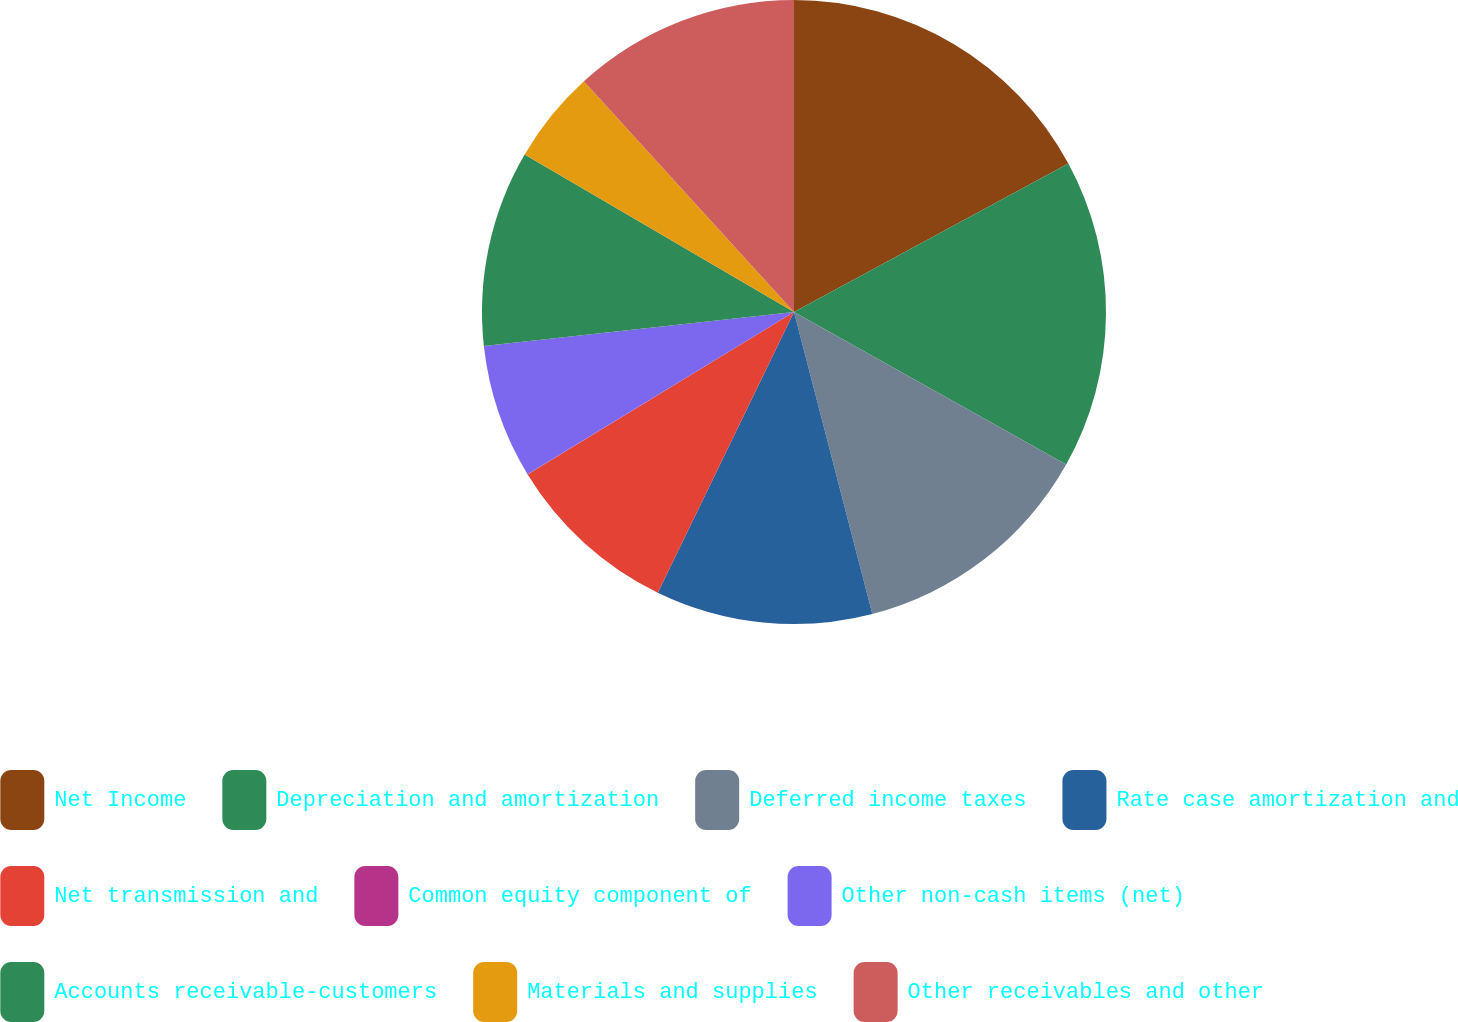Convert chart to OTSL. <chart><loc_0><loc_0><loc_500><loc_500><pie_chart><fcel>Net Income<fcel>Depreciation and amortization<fcel>Deferred income taxes<fcel>Rate case amortization and<fcel>Net transmission and<fcel>Common equity component of<fcel>Other non-cash items (net)<fcel>Accounts receivable-customers<fcel>Materials and supplies<fcel>Other receivables and other<nl><fcel>17.1%<fcel>16.03%<fcel>12.83%<fcel>11.23%<fcel>9.09%<fcel>0.02%<fcel>6.96%<fcel>10.16%<fcel>4.82%<fcel>11.76%<nl></chart> 